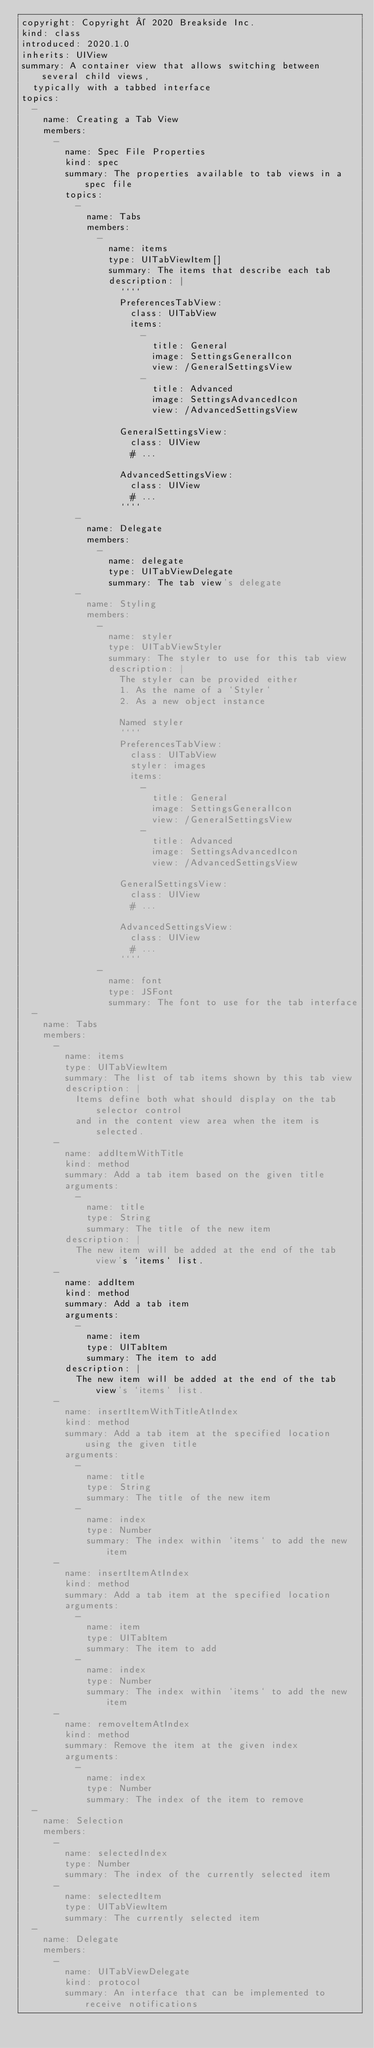<code> <loc_0><loc_0><loc_500><loc_500><_YAML_>copyright: Copyright © 2020 Breakside Inc.
kind: class
introduced: 2020.1.0
inherits: UIView
summary: A container view that allows switching between several child views,
  typically with a tabbed interface
topics:
  -
    name: Creating a Tab View
    members:
      -
        name: Spec File Properties
        kind: spec
        summary: The properties available to tab views in a spec file
        topics:
          -
            name: Tabs
            members:
              -
                name: items
                type: UITabViewItem[]
                summary: The items that describe each tab
                description: |
                  ````
                  PreferencesTabView:
                    class: UITabView
                    items:
                      -
                        title: General
                        image: SettingsGeneralIcon
                        view: /GeneralSettingsView
                      -
                        title: Advanced
                        image: SettingsAdvancedIcon
                        view: /AdvancedSettingsView

                  GeneralSettingsView:
                    class: UIView
                    # ...

                  AdvancedSettingsView:
                    class: UIView
                    # ...
                  ````
          -
            name: Delegate
            members:
              -
                name: delegate
                type: UITabViewDelegate
                summary: The tab view's delegate
          -
            name: Styling
            members:
              -
                name: styler
                type: UITabViewStyler
                summary: The styler to use for this tab view
                description: |
                  The styler can be provided either
                  1. As the name of a `Styler`
                  2. As a new object instance

                  Named styler
                  ````
                  PreferencesTabView:
                    class: UITabView
                    styler: images
                    items:
                      -
                        title: General
                        image: SettingsGeneralIcon
                        view: /GeneralSettingsView
                      -
                        title: Advanced
                        image: SettingsAdvancedIcon
                        view: /AdvancedSettingsView

                  GeneralSettingsView:
                    class: UIView
                    # ...

                  AdvancedSettingsView:
                    class: UIView
                    # ...
                  ````
              -
                name: font
                type: JSFont
                summary: The font to use for the tab interface
  -
    name: Tabs
    members:
      -
        name: items
        type: UITabViewItem
        summary: The list of tab items shown by this tab view
        description: |
          Items define both what should display on the tab selector control
          and in the content view area when the item is selected.
      -
        name: addItemWithTitle
        kind: method
        summary: Add a tab item based on the given title
        arguments:
          -
            name: title
            type: String
            summary: The title of the new item
        description: |
          The new item will be added at the end of the tab view's `items` list.
      -
        name: addItem
        kind: method
        summary: Add a tab item
        arguments:
          -
            name: item
            type: UITabItem
            summary: The item to add
        description: |
          The new item will be added at the end of the tab view's `items` list.
      -
        name: insertItemWithTitleAtIndex
        kind: method
        summary: Add a tab item at the specified location using the given title
        arguments:
          -
            name: title
            type: String
            summary: The title of the new item
          -
            name: index
            type: Number
            summary: The index within `items` to add the new item
      -
        name: insertItemAtIndex
        kind: method
        summary: Add a tab item at the specified location
        arguments:
          -
            name: item
            type: UITabItem
            summary: The item to add
          -
            name: index
            type: Number
            summary: The index within `items` to add the new item
      -
        name: removeItemAtIndex
        kind: method
        summary: Remove the item at the given index
        arguments:
          -
            name: index
            type: Number
            summary: The index of the item to remove
  -
    name: Selection
    members:
      -
        name: selectedIndex
        type: Number
        summary: The index of the currently selected item
      -
        name: selectedItem
        type: UITabViewItem
        summary: The currently selected item
  -
    name: Delegate
    members:
      -
        name: UITabViewDelegate
        kind: protocol
        summary: An interface that can be implemented to receive notifications</code> 